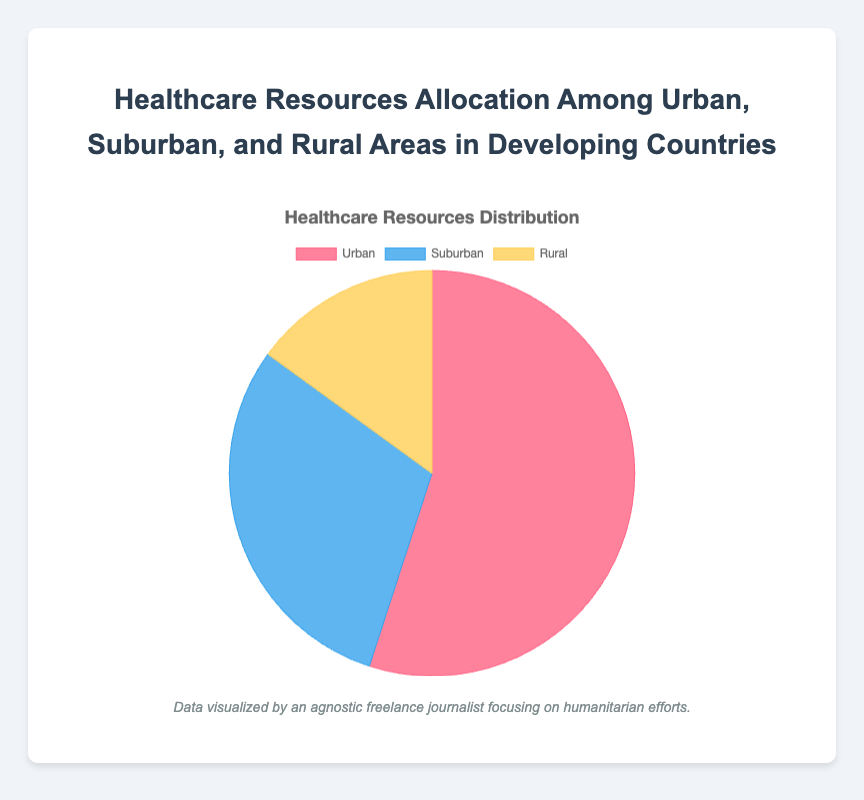What percentage of healthcare resources is allocated to Urban areas? The pie chart shows that 55% of healthcare resources are allocated to Urban areas.
Answer: 55% How does the resource allocation in Suburban areas compare to Rural areas? The pie chart shows that Suburban areas receive 30% of resources whereas Rural areas receive only 15%. Therefore, Suburban areas receive twice the resources than Rural areas.
Answer: Suburban areas receive twice the resources than Rural areas Which area receives the least healthcare resources? According to the pie chart, Rural areas receive the least healthcare resources at 15%.
Answer: Rural areas What is the combined percentage of healthcare resources allocated to Suburban and Rural areas? The percentages for Suburban and Rural areas are 30% and 15%, respectively. Adding them together gives: 30% + 15% = 45%.
Answer: 45% Is the allocation to Urban areas greater than the combined allocation to Suburban and Rural areas? The allocation to Urban areas is 55%, while the combined allocation to Suburban and Rural areas is 45%. Since 55% is greater than 45%, Urban areas receive a greater allocation.
Answer: Yes What is the difference in the percentage allocation between Urban and Suburban areas? The percentage for Urban areas is 55%, and for Suburban areas it is 30%. The difference is 55% - 30% = 25%.
Answer: 25% What proportion of the total healthcare resources is not allocated to Urban areas? The total percentage not allocated to Urban areas is the sum of Suburban and Rural areas' allocations: 30% + 15% = 45%.
Answer: 45% Identify the color representing Suburban areas in the pie chart. The pie chart uses colors to represent different areas. According to the segments, Suburban areas are represented by the color blue.
Answer: Blue Compare the allocation between Urban and Rural areas and determine by how much it differs. Urban areas have a 55% allocation, while Rural areas have 15%. The difference between their allocations is 55% - 15% = 40%.
Answer: 40% What is the ratio of healthcare resources allocated to Urban areas compared to Rural areas? The allocation to Urban areas is 55% and to Rural areas is 15%. The ratio of Urban to Rural is 55:15, which simplifies to 11:3.
Answer: 11:3 